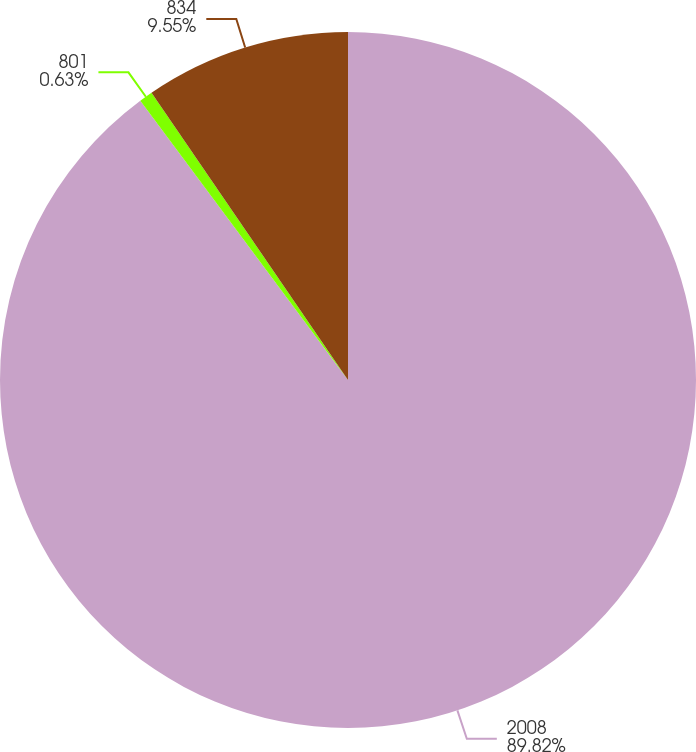Convert chart to OTSL. <chart><loc_0><loc_0><loc_500><loc_500><pie_chart><fcel>2008<fcel>801<fcel>834<nl><fcel>89.83%<fcel>0.63%<fcel>9.55%<nl></chart> 